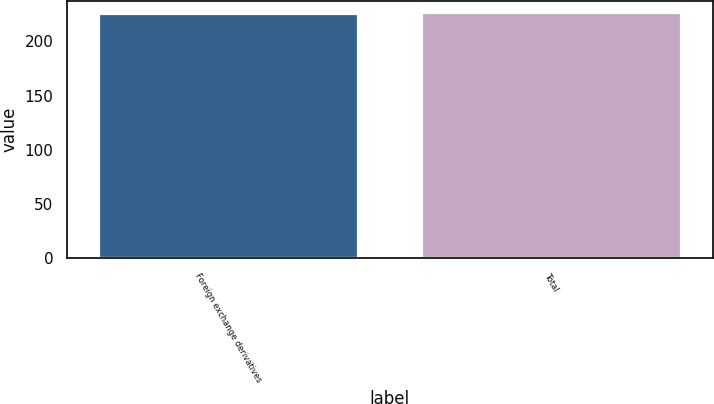<chart> <loc_0><loc_0><loc_500><loc_500><bar_chart><fcel>Foreign exchange derivatives<fcel>Total<nl><fcel>225<fcel>226<nl></chart> 